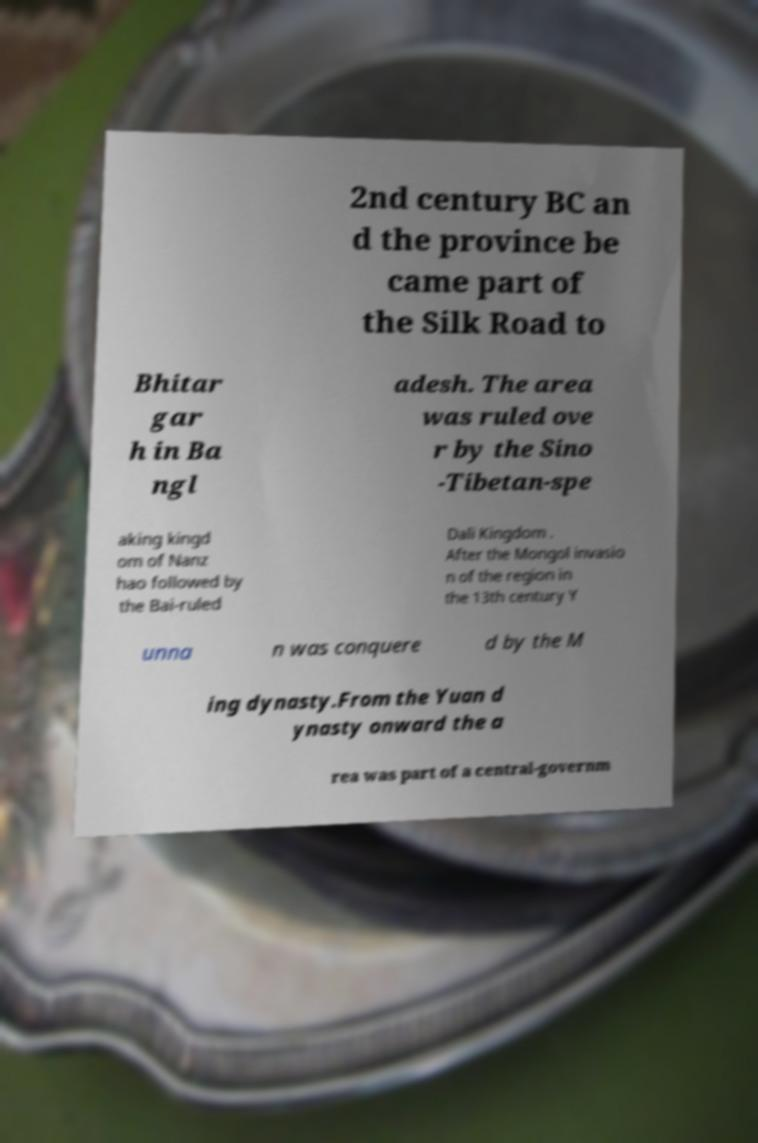For documentation purposes, I need the text within this image transcribed. Could you provide that? 2nd century BC an d the province be came part of the Silk Road to Bhitar gar h in Ba ngl adesh. The area was ruled ove r by the Sino -Tibetan-spe aking kingd om of Nanz hao followed by the Bai-ruled Dali Kingdom . After the Mongol invasio n of the region in the 13th century Y unna n was conquere d by the M ing dynasty.From the Yuan d ynasty onward the a rea was part of a central-governm 